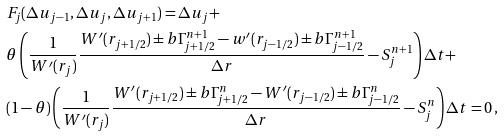<formula> <loc_0><loc_0><loc_500><loc_500>& F _ { j } ( \Delta u _ { j - 1 } , \Delta u _ { j } , \Delta u _ { j + 1 } ) = \Delta u _ { j } + \\ & \theta \left ( \frac { 1 } { W ^ { \prime } ( r _ { j } ) } \frac { W ^ { \prime } ( r _ { j + 1 / 2 } ) \pm b { \Gamma } ^ { n + 1 } _ { j + 1 / 2 } - w ^ { \prime } ( r _ { j - 1 / 2 } ) \pm b { \Gamma } ^ { n + 1 } _ { j - 1 / 2 } } { \Delta r } - S ^ { n + 1 } _ { j } \right ) \Delta t + \\ & ( 1 - \theta ) \left ( \frac { 1 } { W ^ { \prime } ( r _ { j } ) } \frac { W ^ { \prime } ( r _ { j + 1 / 2 } ) \pm b { \Gamma } ^ { n } _ { j + 1 / 2 } - W ^ { \prime } ( r _ { j - 1 / 2 } ) \pm b { \Gamma } ^ { n } _ { j - 1 / 2 } } { \Delta r } - S ^ { n } _ { j } \right ) \Delta t = 0 \, , \\</formula> 